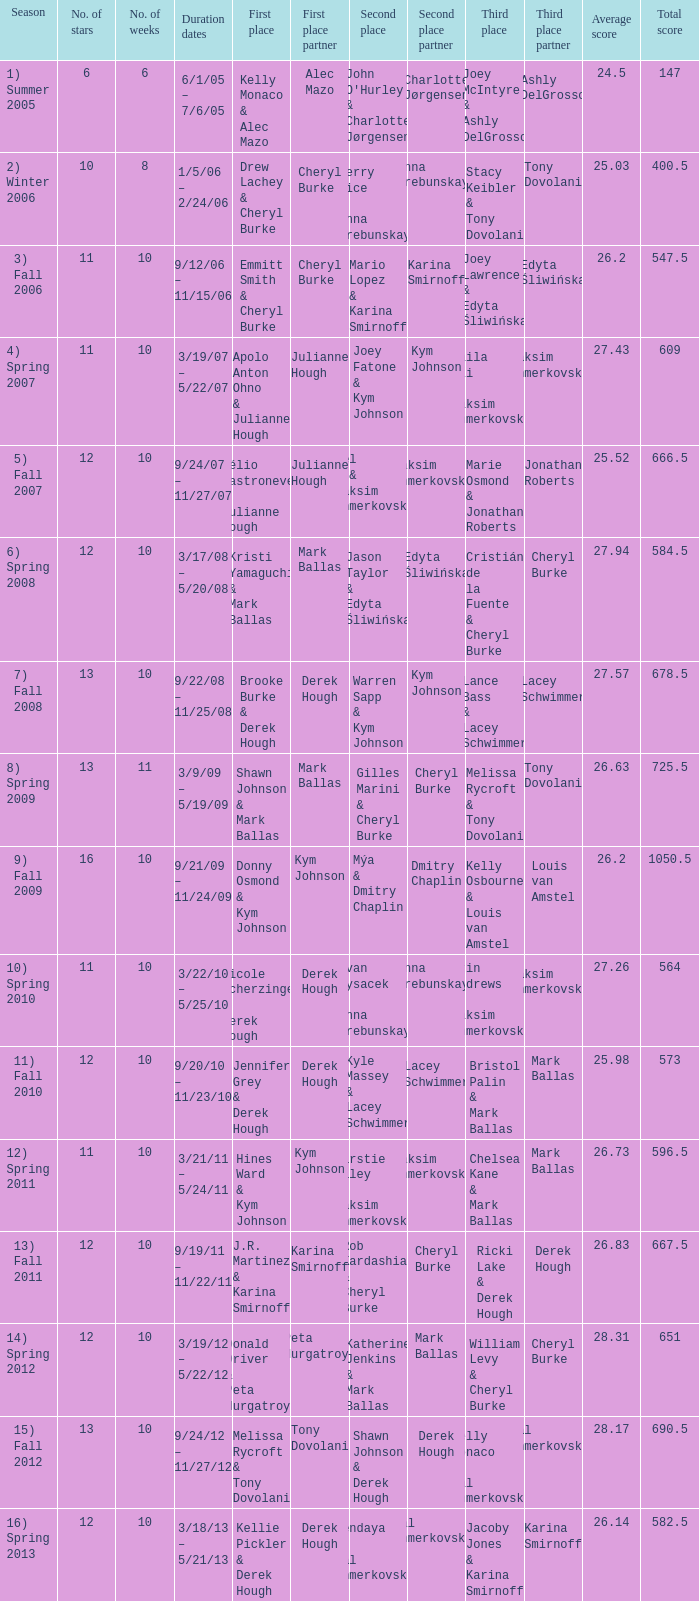Who took first place in week 6? 1.0. 